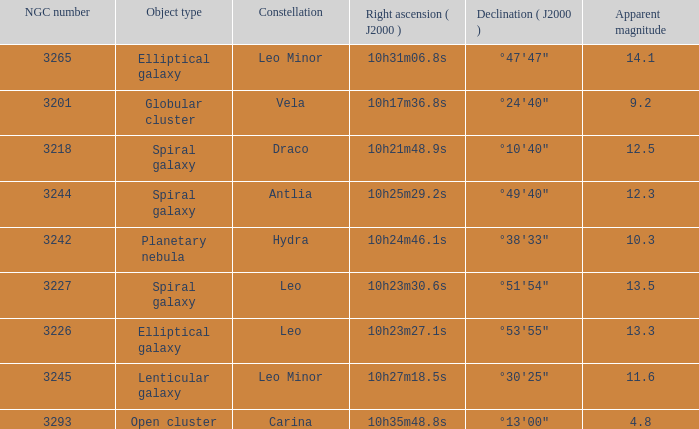What is the sum of NGC numbers for Constellation vela? 3201.0. 